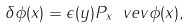<formula> <loc_0><loc_0><loc_500><loc_500>\delta \phi ( x ) = \epsilon ( y ) P _ { x } \ v e v { \phi ( x ) } ,</formula> 